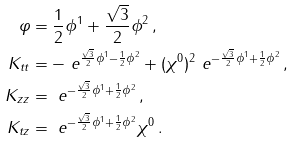Convert formula to latex. <formula><loc_0><loc_0><loc_500><loc_500>\varphi & = \frac { 1 } { 2 } \phi ^ { 1 } + \frac { \sqrt { 3 } } { 2 } \phi ^ { 2 } \, , \\ K _ { t t } & = - \ e ^ { \frac { \sqrt { 3 } } { 2 } \phi ^ { 1 } - \frac { 1 } { 2 } \phi ^ { 2 } } + ( \chi ^ { 0 } ) ^ { 2 } \ e ^ { - \frac { \sqrt { 3 } } { 2 } \phi ^ { 1 } + \frac { 1 } { 2 } \phi ^ { 2 } } \, , \\ K _ { z z } & = \ e ^ { - \frac { \sqrt { 3 } } { 2 } \phi ^ { 1 } + \frac { 1 } { 2 } \phi ^ { 2 } } \, , \\ K _ { t z } & = \ e ^ { - \frac { \sqrt { 3 } } { 2 } \phi ^ { 1 } + \frac { 1 } { 2 } \phi ^ { 2 } } \chi ^ { 0 } \, .</formula> 